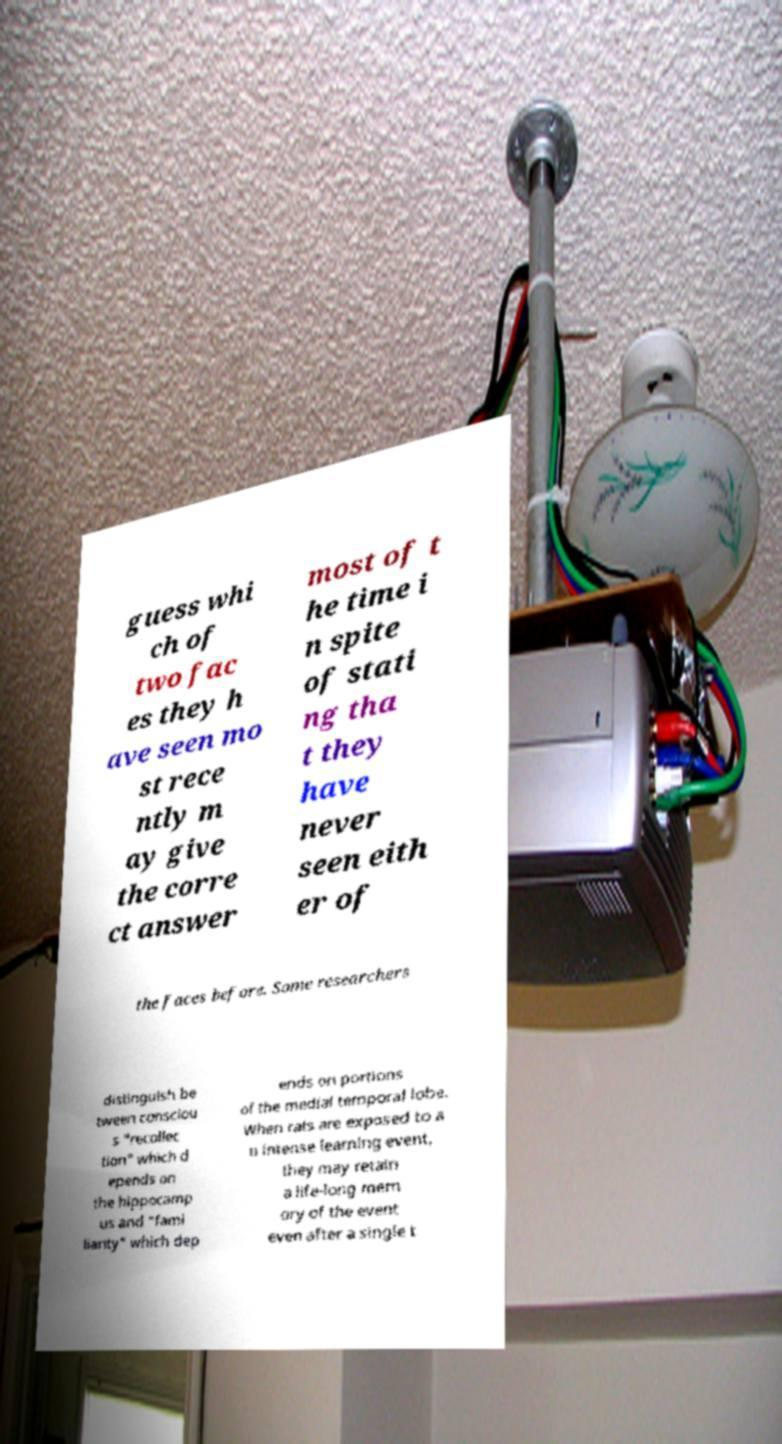Can you accurately transcribe the text from the provided image for me? guess whi ch of two fac es they h ave seen mo st rece ntly m ay give the corre ct answer most of t he time i n spite of stati ng tha t they have never seen eith er of the faces before. Some researchers distinguish be tween consciou s "recollec tion" which d epends on the hippocamp us and "fami liarity" which dep ends on portions of the medial temporal lobe. When rats are exposed to a n intense learning event, they may retain a life-long mem ory of the event even after a single t 